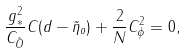Convert formula to latex. <formula><loc_0><loc_0><loc_500><loc_500>\frac { g _ { * } ^ { 2 } } { C _ { \tilde { O } } } C ( d - \tilde { \eta } _ { o } ) + \frac { 2 } { N } C _ { \phi } ^ { 2 } = 0 ,</formula> 